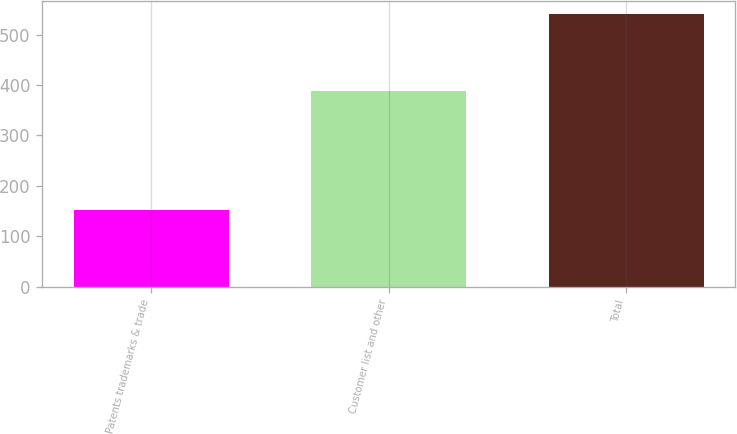Convert chart to OTSL. <chart><loc_0><loc_0><loc_500><loc_500><bar_chart><fcel>Patents trademarks & trade<fcel>Customer list and other<fcel>Total<nl><fcel>152<fcel>388<fcel>540<nl></chart> 